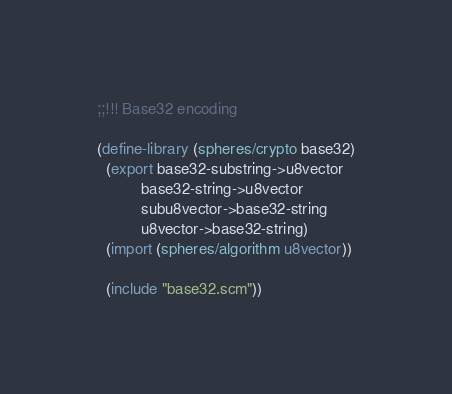<code> <loc_0><loc_0><loc_500><loc_500><_Scheme_>;;!!! Base32 encoding

(define-library (spheres/crypto base32)
  (export base32-substring->u8vector
          base32-string->u8vector
          subu8vector->base32-string
          u8vector->base32-string)
  (import (spheres/algorithm u8vector))

  (include "base32.scm"))
</code> 